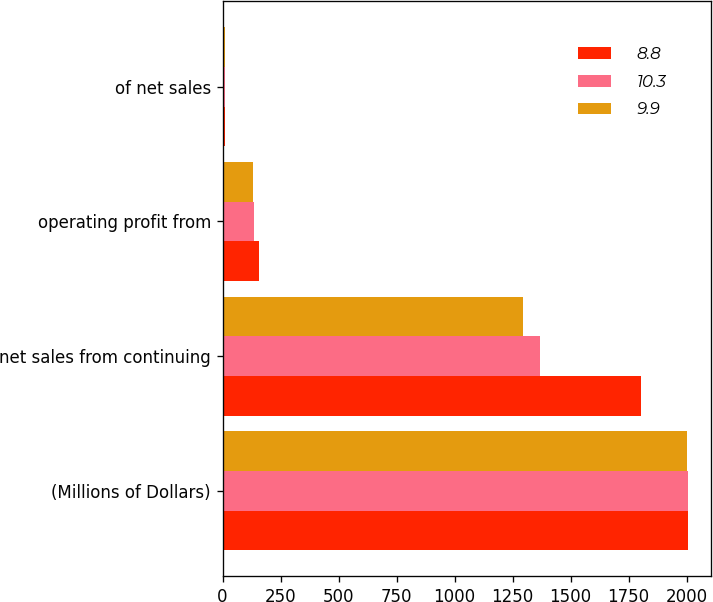Convert chart to OTSL. <chart><loc_0><loc_0><loc_500><loc_500><stacked_bar_chart><ecel><fcel>(Millions of Dollars)<fcel>net sales from continuing<fcel>operating profit from<fcel>of net sales<nl><fcel>8.8<fcel>2006<fcel>1803<fcel>159<fcel>8.8<nl><fcel>10.3<fcel>2005<fcel>1370<fcel>136<fcel>9.9<nl><fcel>9.9<fcel>2004<fcel>1293<fcel>133<fcel>10.3<nl></chart> 